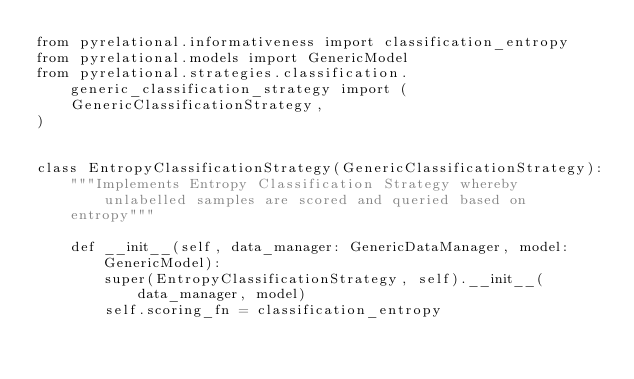Convert code to text. <code><loc_0><loc_0><loc_500><loc_500><_Python_>from pyrelational.informativeness import classification_entropy
from pyrelational.models import GenericModel
from pyrelational.strategies.classification.generic_classification_strategy import (
    GenericClassificationStrategy,
)


class EntropyClassificationStrategy(GenericClassificationStrategy):
    """Implements Entropy Classification Strategy whereby unlabelled samples are scored and queried based on
    entropy"""

    def __init__(self, data_manager: GenericDataManager, model: GenericModel):
        super(EntropyClassificationStrategy, self).__init__(data_manager, model)
        self.scoring_fn = classification_entropy
</code> 